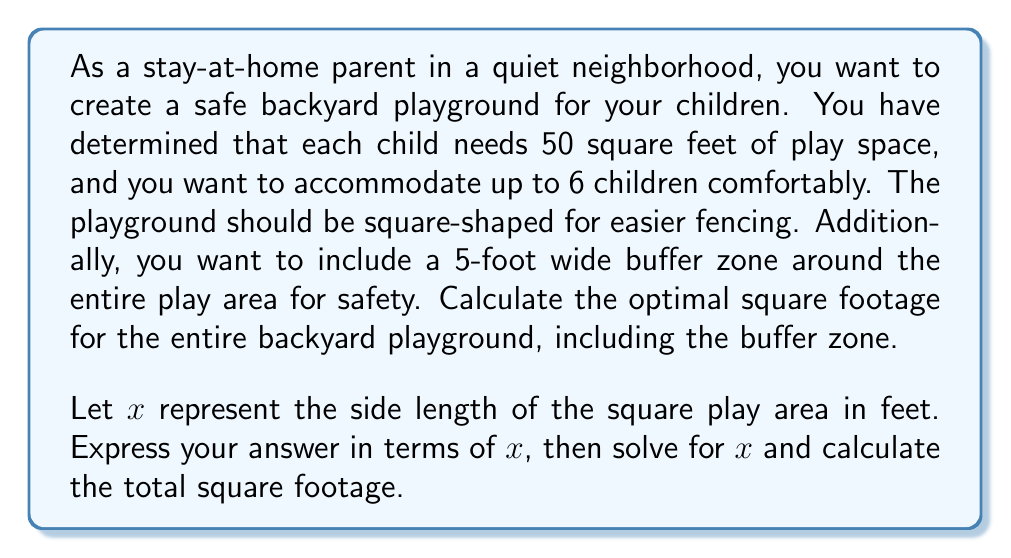Help me with this question. Let's approach this problem step-by-step:

1) First, we need to ensure the play area can accommodate 6 children, each needing 50 square feet:

   $6 \times 50 = 300$ square feet minimum

2) Since the play area is square, we can express this as:

   $x^2 \geq 300$

3) Now, we need to include the buffer zone. The total side length will be $x + 10$ (5 feet on each side).

4) The total area of the playground, including the buffer zone, will be:

   $A = (x + 10)^2$

5) To find the optimal size, we want the play area to be exactly 300 square feet:

   $x^2 = 300$
   $x = \sqrt{300} = 10\sqrt{3} \approx 17.32$ feet

6) Now we can calculate the total area:

   $A = (10\sqrt{3} + 10)^2$
   $A = (10(\sqrt{3} + 1))^2$
   $A = 100(\sqrt{3} + 1)^2$
   $A = 100(3 + 2\sqrt{3} + 1)$
   $A = 100(4 + 2\sqrt{3})$
   $A = 400 + 200\sqrt{3}$

7) To get a numeric value:

   $A \approx 400 + 200 \times 1.732 \approx 746.4$ square feet
Answer: The optimal square footage for the backyard playground, including the buffer zone, is $400 + 200\sqrt{3}$ square feet, or approximately 746.4 square feet. 